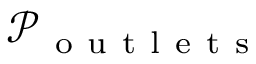Convert formula to latex. <formula><loc_0><loc_0><loc_500><loc_500>\mathcal { P } _ { o u t l e t s }</formula> 